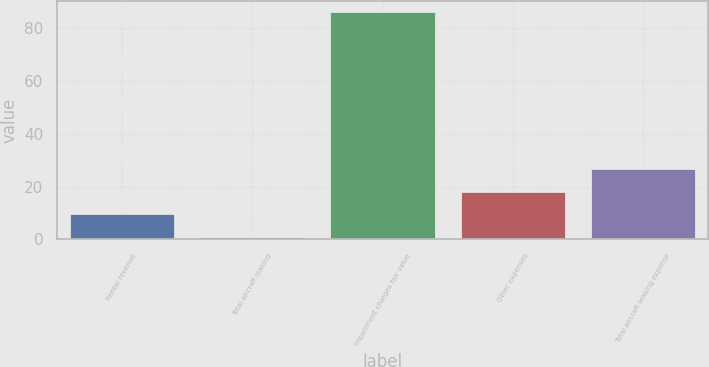Convert chart to OTSL. <chart><loc_0><loc_0><loc_500><loc_500><bar_chart><fcel>Rental revenue<fcel>Total aircraft leasing<fcel>Impairment charges fair value<fcel>Other expenses<fcel>Total aircraft leasing expense<nl><fcel>9.5<fcel>1<fcel>86<fcel>18<fcel>26.5<nl></chart> 